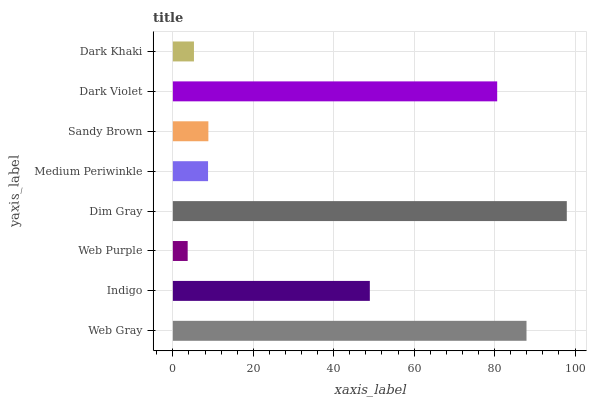Is Web Purple the minimum?
Answer yes or no. Yes. Is Dim Gray the maximum?
Answer yes or no. Yes. Is Indigo the minimum?
Answer yes or no. No. Is Indigo the maximum?
Answer yes or no. No. Is Web Gray greater than Indigo?
Answer yes or no. Yes. Is Indigo less than Web Gray?
Answer yes or no. Yes. Is Indigo greater than Web Gray?
Answer yes or no. No. Is Web Gray less than Indigo?
Answer yes or no. No. Is Indigo the high median?
Answer yes or no. Yes. Is Sandy Brown the low median?
Answer yes or no. Yes. Is Dim Gray the high median?
Answer yes or no. No. Is Dark Khaki the low median?
Answer yes or no. No. 